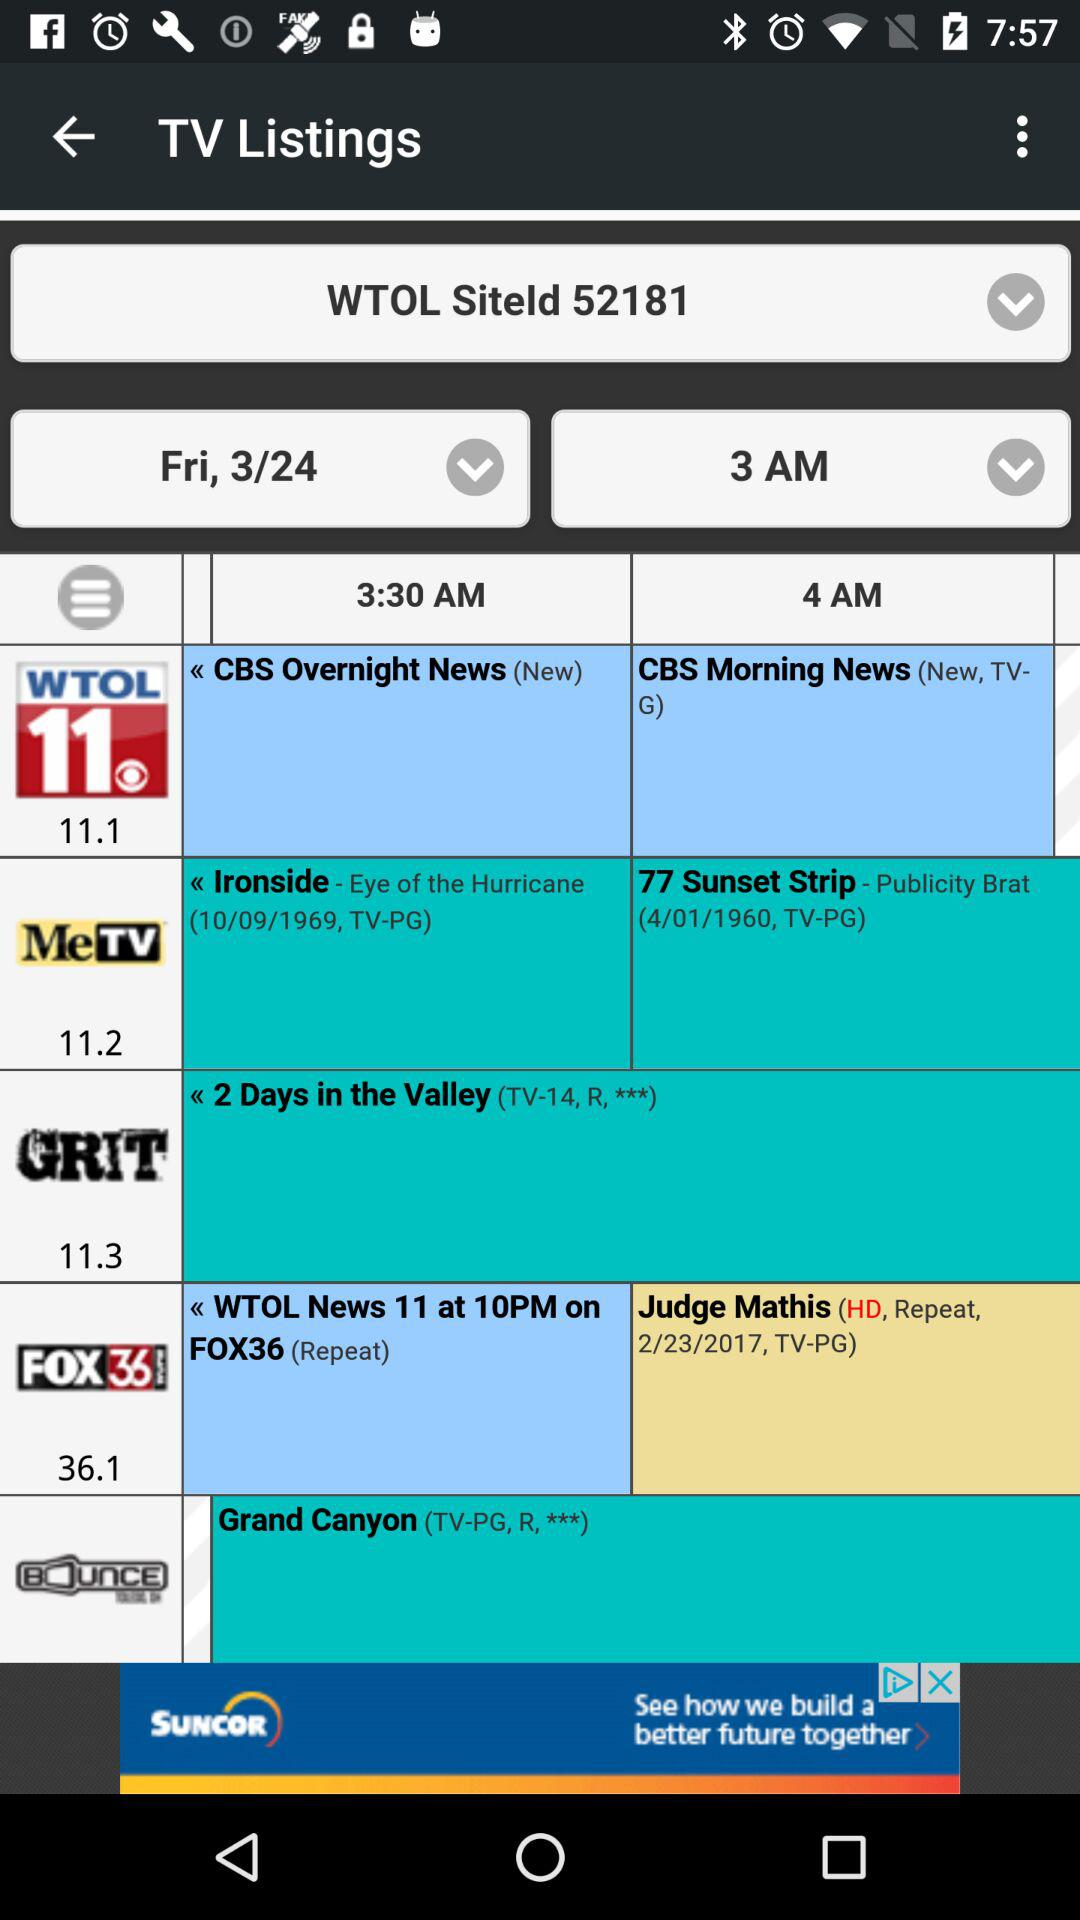What is the time of "CBS Overnight News"? "CBS Overnight News" starts at 3:30 AM. 